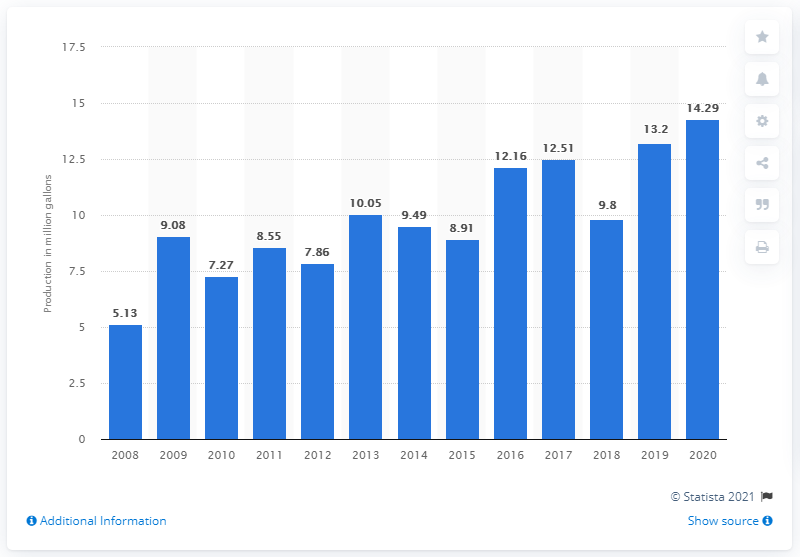Specify some key components in this picture. In 2020, the production of maple syrup in Canada was estimated to be 14.29 million gallons. 